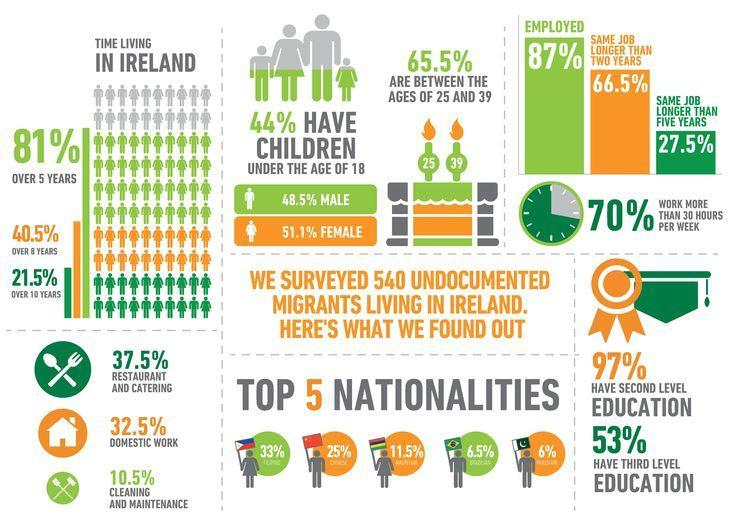What percentage of people are employed in Ireland?
Answer the question with a short phrase. 87% What percentage of people have same job for more than two years in Ireland? 66.5% What percentage of Irish people are involved in restaurant & catering works? 37.5% What percentage of Irish people are involved in domestic works? 32.5% What percentage of people are living in Ireland for over 10 years? 21.5% What percentage of people are living in Ireland for over 8 years? 40.5% What percentage of people in Ireland do not work more than 30 hours per week? 30% What percentage of people have same job for more than 5 years in Ireland? 27.5% 